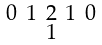Convert formula to latex. <formula><loc_0><loc_0><loc_500><loc_500>\begin{smallmatrix} 0 & 1 & 2 & 1 & 0 \\ & & 1 & & \end{smallmatrix}</formula> 